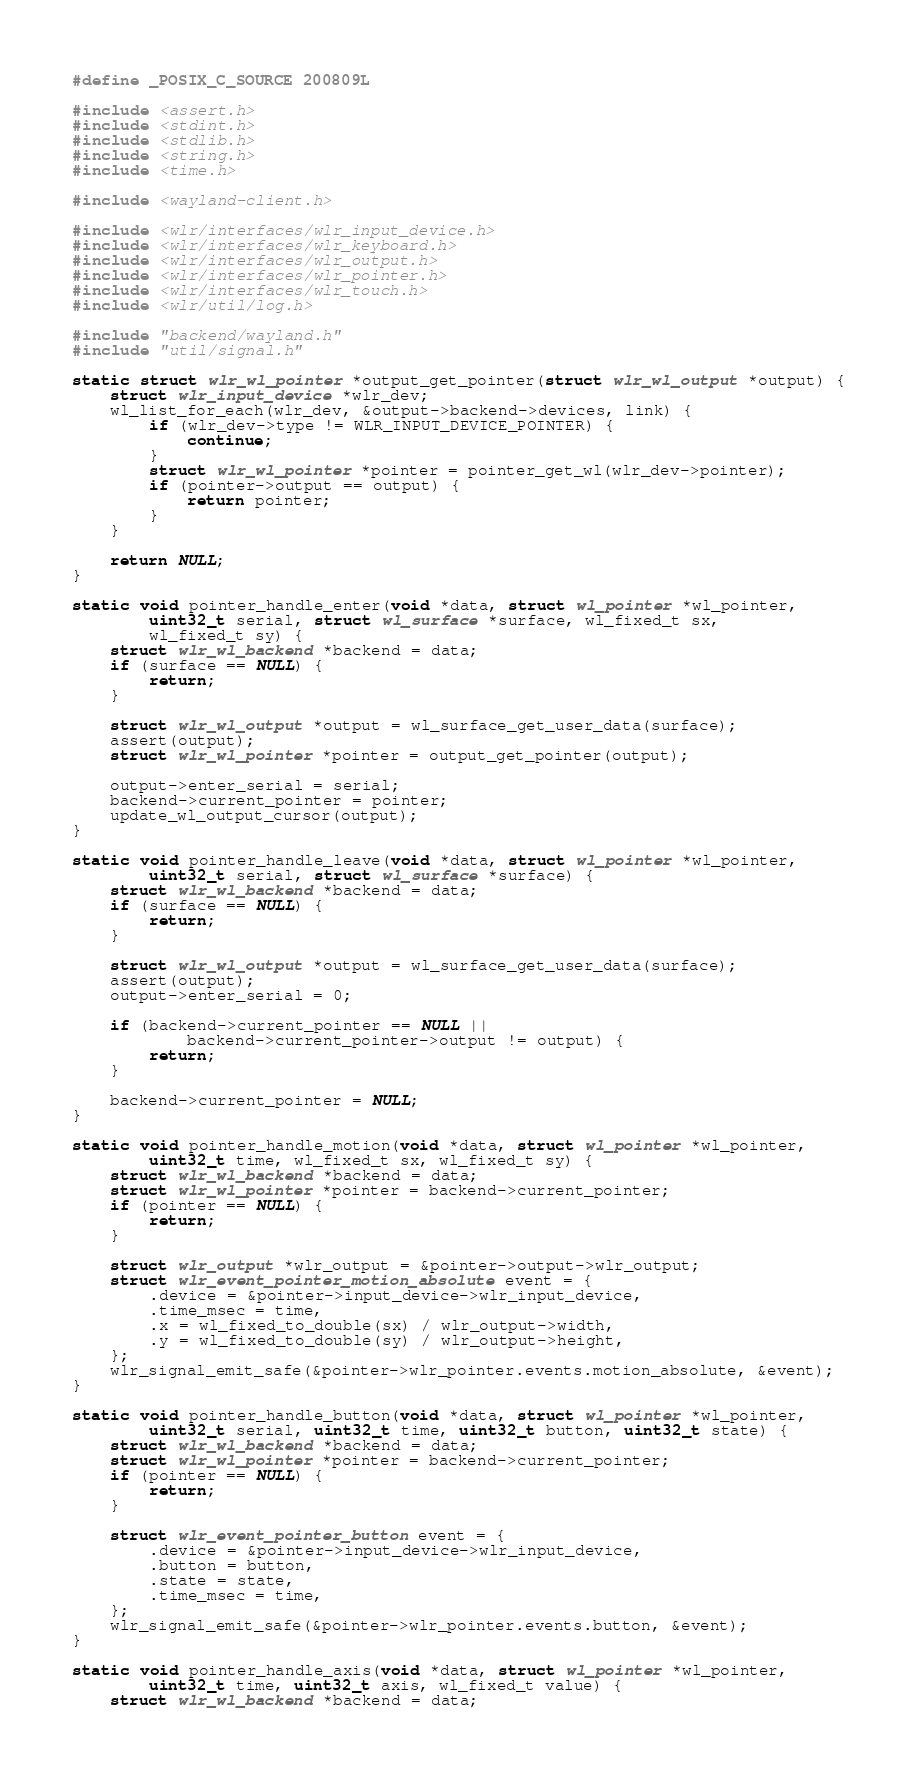<code> <loc_0><loc_0><loc_500><loc_500><_C_>#define _POSIX_C_SOURCE 200809L

#include <assert.h>
#include <stdint.h>
#include <stdlib.h>
#include <string.h>
#include <time.h>

#include <wayland-client.h>

#include <wlr/interfaces/wlr_input_device.h>
#include <wlr/interfaces/wlr_keyboard.h>
#include <wlr/interfaces/wlr_output.h>
#include <wlr/interfaces/wlr_pointer.h>
#include <wlr/interfaces/wlr_touch.h>
#include <wlr/util/log.h>

#include "backend/wayland.h"
#include "util/signal.h"

static struct wlr_wl_pointer *output_get_pointer(struct wlr_wl_output *output) {
	struct wlr_input_device *wlr_dev;
	wl_list_for_each(wlr_dev, &output->backend->devices, link) {
		if (wlr_dev->type != WLR_INPUT_DEVICE_POINTER) {
			continue;
		}
		struct wlr_wl_pointer *pointer = pointer_get_wl(wlr_dev->pointer);
		if (pointer->output == output) {
			return pointer;
		}
	}

	return NULL;
}

static void pointer_handle_enter(void *data, struct wl_pointer *wl_pointer,
		uint32_t serial, struct wl_surface *surface, wl_fixed_t sx,
		wl_fixed_t sy) {
	struct wlr_wl_backend *backend = data;
	if (surface == NULL) {
		return;
	}

	struct wlr_wl_output *output = wl_surface_get_user_data(surface);
	assert(output);
	struct wlr_wl_pointer *pointer = output_get_pointer(output);

	output->enter_serial = serial;
	backend->current_pointer = pointer;
	update_wl_output_cursor(output);
}

static void pointer_handle_leave(void *data, struct wl_pointer *wl_pointer,
		uint32_t serial, struct wl_surface *surface) {
	struct wlr_wl_backend *backend = data;
	if (surface == NULL) {
		return;
	}

	struct wlr_wl_output *output = wl_surface_get_user_data(surface);
	assert(output);
	output->enter_serial = 0;

	if (backend->current_pointer == NULL ||
			backend->current_pointer->output != output) {
		return;
	}

	backend->current_pointer = NULL;
}

static void pointer_handle_motion(void *data, struct wl_pointer *wl_pointer,
		uint32_t time, wl_fixed_t sx, wl_fixed_t sy) {
	struct wlr_wl_backend *backend = data;
	struct wlr_wl_pointer *pointer = backend->current_pointer;
	if (pointer == NULL) {
		return;
	}

	struct wlr_output *wlr_output = &pointer->output->wlr_output;
	struct wlr_event_pointer_motion_absolute event = {
		.device = &pointer->input_device->wlr_input_device,
		.time_msec = time,
		.x = wl_fixed_to_double(sx) / wlr_output->width,
		.y = wl_fixed_to_double(sy) / wlr_output->height,
	};
	wlr_signal_emit_safe(&pointer->wlr_pointer.events.motion_absolute, &event);
}

static void pointer_handle_button(void *data, struct wl_pointer *wl_pointer,
		uint32_t serial, uint32_t time, uint32_t button, uint32_t state) {
	struct wlr_wl_backend *backend = data;
	struct wlr_wl_pointer *pointer = backend->current_pointer;
	if (pointer == NULL) {
		return;
	}

	struct wlr_event_pointer_button event = {
		.device = &pointer->input_device->wlr_input_device,
		.button = button,
		.state = state,
		.time_msec = time,
	};
	wlr_signal_emit_safe(&pointer->wlr_pointer.events.button, &event);
}

static void pointer_handle_axis(void *data, struct wl_pointer *wl_pointer,
		uint32_t time, uint32_t axis, wl_fixed_t value) {
	struct wlr_wl_backend *backend = data;</code> 